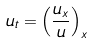Convert formula to latex. <formula><loc_0><loc_0><loc_500><loc_500>u _ { t } = \left ( \frac { u _ { x } } u \right ) _ { x }</formula> 